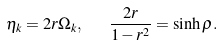<formula> <loc_0><loc_0><loc_500><loc_500>\eta _ { k } = 2 r \Omega _ { k } , \text { \ \ } \frac { 2 r } { 1 - r ^ { 2 } } = \sinh \rho .</formula> 